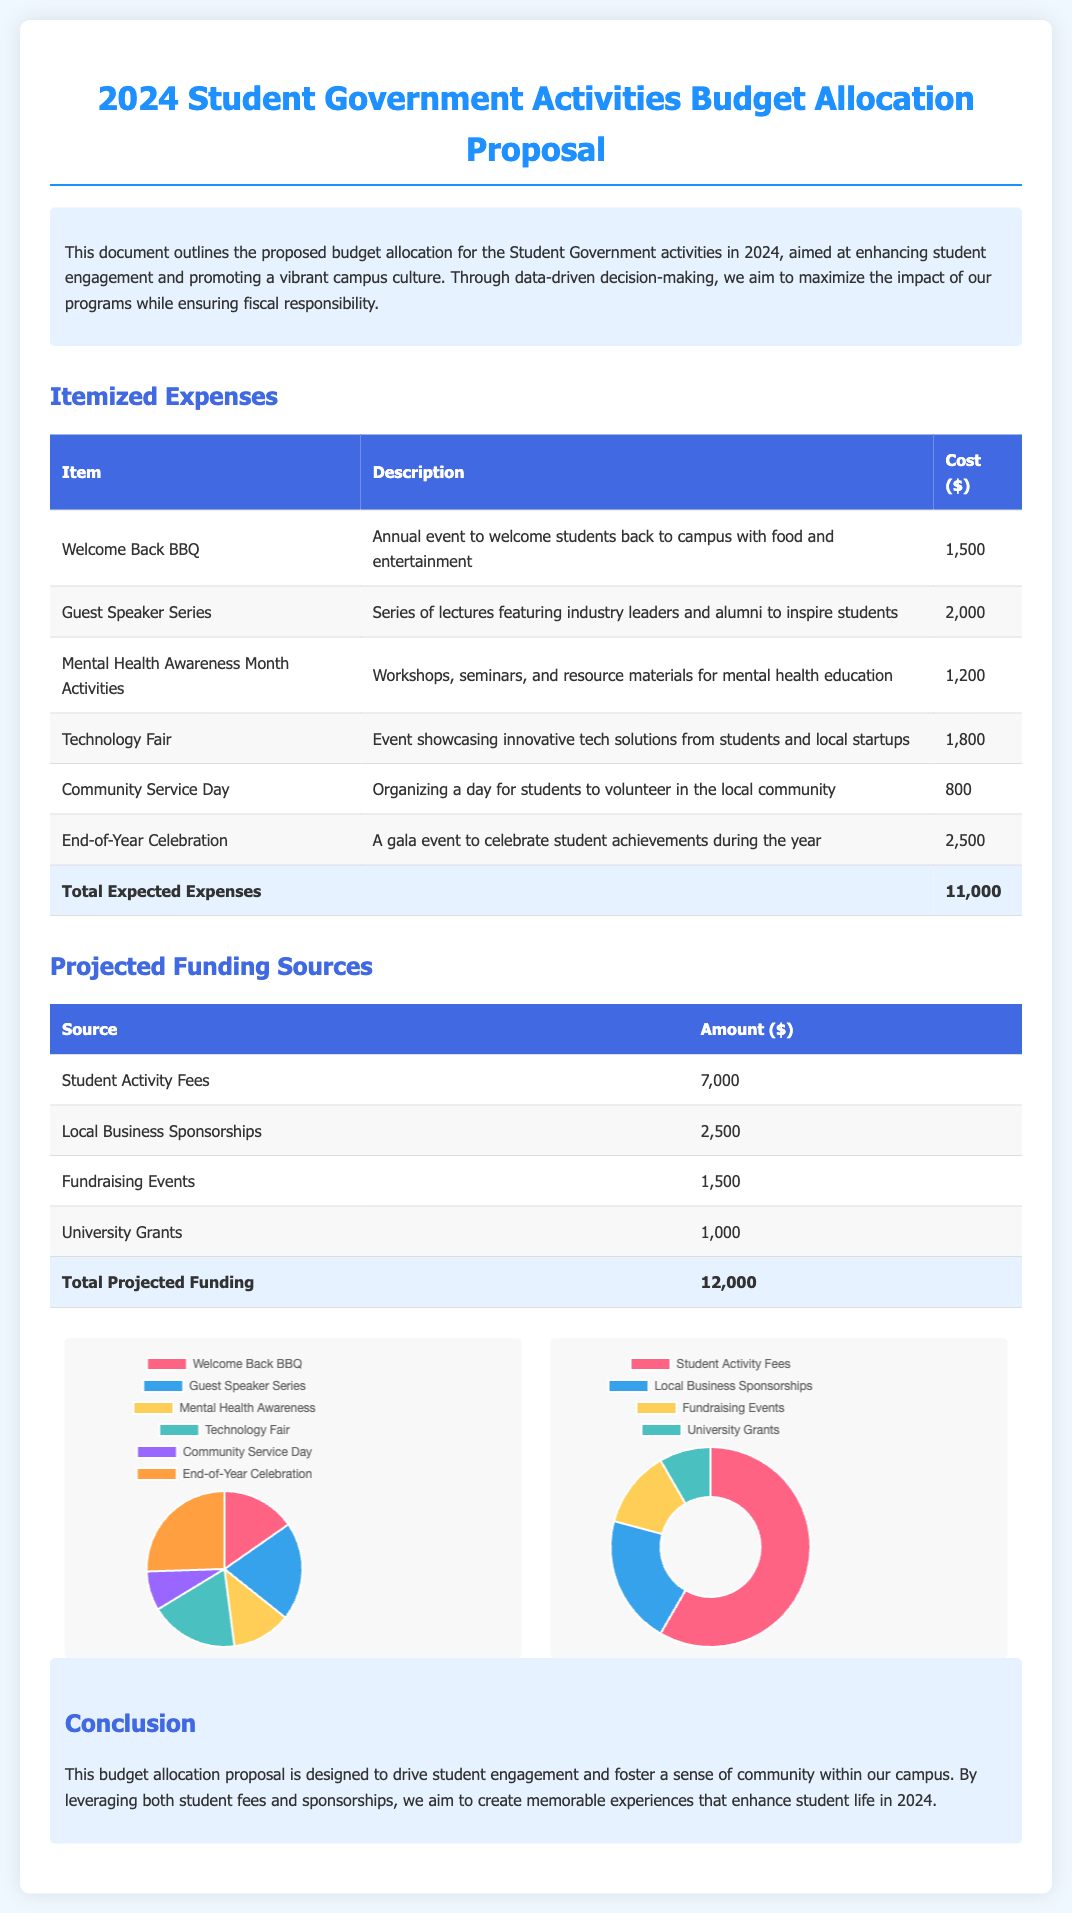What is the total expected expenses? The total expected expenses are calculated by summing all itemized expenses listed in the document, resulting in $1500 + $2000 + $1200 + $1800 + $800 + $2500.
Answer: $11,000 How much funding comes from local business sponsorships? The amount allocated from local business sponsorships is specifically stated in the funding sources section of the document.
Answer: $2,500 What event has the highest cost? The itemized expenses section lists the costs of each event, with the end-of-year celebration costing the most.
Answer: End-of-Year Celebration What is the purpose of the Mental Health Awareness Month Activities? The description provided in the document details that the activities are for workshops, seminars, and resource materials aimed at education.
Answer: Education What percentage of the total budget comes from student activity fees? By calculating the proportion of student activity fees to the total projected funding, we find it contributes $7000 of the total $12000.
Answer: 58.33% Which chart type is used for visualizing the funding sources? The document specifies the type of chart used to represent funding sources.
Answer: Doughnut What is the budget allocation proposal aiming to enhance? The introductory section clearly states the primary goal of the proposal in relation to student engagement.
Answer: Student Engagement How many projects/events are listed in the itemized expenses? The number can be determined directly by counting the number of lines representing individual expenses.
Answer: 6 